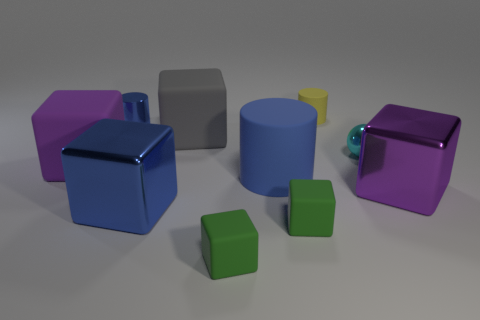Is the purple block that is on the left side of the small yellow cylinder made of the same material as the sphere?
Make the answer very short. No. The purple object behind the purple object that is on the right side of the purple thing behind the large blue cylinder is made of what material?
Provide a short and direct response. Rubber. What number of metallic things are either big purple things or green objects?
Offer a terse response. 1. Are any tiny blue blocks visible?
Keep it short and to the point. No. What color is the large rubber object that is in front of the purple block that is to the left of the yellow object?
Offer a very short reply. Blue. What number of other objects are there of the same color as the big cylinder?
Offer a terse response. 2. What number of things are large cyan rubber cylinders or tiny yellow rubber cylinders left of the shiny sphere?
Offer a very short reply. 1. There is a rubber object that is on the left side of the large gray cube; what is its color?
Your answer should be very brief. Purple. What is the shape of the gray object?
Offer a very short reply. Cube. There is a large purple block that is right of the large blue thing in front of the blue rubber cylinder; what is it made of?
Give a very brief answer. Metal. 